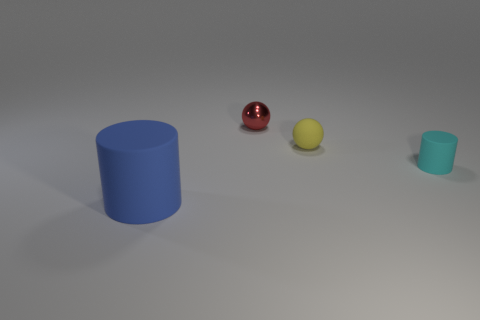There is a thing that is both left of the yellow matte object and behind the cyan matte object; what is its material?
Offer a terse response. Metal. What number of small matte things are on the left side of the small cyan rubber cylinder on the right side of the tiny yellow ball?
Give a very brief answer. 1. What is the shape of the tiny red object?
Make the answer very short. Sphere. There is a yellow object that is made of the same material as the small cyan object; what shape is it?
Your answer should be very brief. Sphere. Does the matte thing behind the small rubber cylinder have the same shape as the red metal object?
Keep it short and to the point. Yes. What is the shape of the tiny object in front of the tiny matte ball?
Provide a short and direct response. Cylinder. What number of other rubber objects have the same size as the cyan rubber object?
Ensure brevity in your answer.  1. What is the color of the metal object?
Give a very brief answer. Red. What size is the blue object that is the same material as the small cylinder?
Offer a terse response. Large. What number of things are matte objects left of the red ball or gray matte balls?
Your response must be concise. 1. 